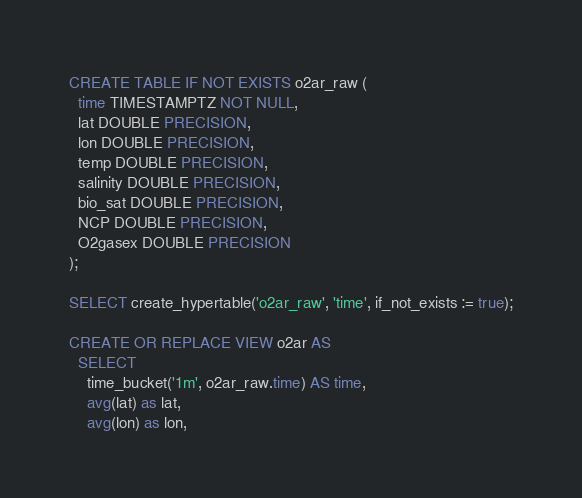<code> <loc_0><loc_0><loc_500><loc_500><_SQL_>CREATE TABLE IF NOT EXISTS o2ar_raw (
  time TIMESTAMPTZ NOT NULL,
  lat DOUBLE PRECISION,
  lon DOUBLE PRECISION,
  temp DOUBLE PRECISION,
  salinity DOUBLE PRECISION,
  bio_sat DOUBLE PRECISION,
  NCP DOUBLE PRECISION,
  O2gasex DOUBLE PRECISION
);

SELECT create_hypertable('o2ar_raw', 'time', if_not_exists := true);

CREATE OR REPLACE VIEW o2ar AS
  SELECT
    time_bucket('1m', o2ar_raw.time) AS time,
    avg(lat) as lat,
    avg(lon) as lon,</code> 